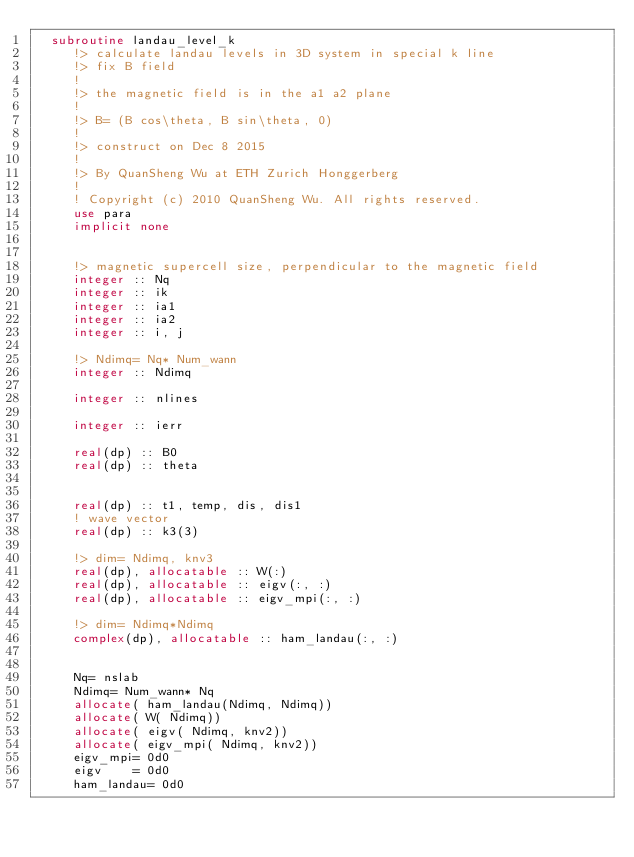Convert code to text. <code><loc_0><loc_0><loc_500><loc_500><_FORTRAN_>  subroutine landau_level_k
     !> calculate landau levels in 3D system in special k line
     !> fix B field
     !
     !> the magnetic field is in the a1 a2 plane
     !
     !> B= (B cos\theta, B sin\theta, 0)
     !
     !> construct on Dec 8 2015
     !
     !> By QuanSheng Wu at ETH Zurich Honggerberg
     !
     ! Copyright (c) 2010 QuanSheng Wu. All rights reserved.
     use para
     implicit none


     !> magnetic supercell size, perpendicular to the magnetic field
     integer :: Nq
     integer :: ik
     integer :: ia1
     integer :: ia2
     integer :: i, j

     !> Ndimq= Nq* Num_wann
     integer :: Ndimq

     integer :: nlines

     integer :: ierr

     real(dp) :: B0
     real(dp) :: theta


     real(dp) :: t1, temp, dis, dis1
     ! wave vector 
     real(dp) :: k3(3)

     !> dim= Ndimq, knv3
     real(dp), allocatable :: W(:)
     real(dp), allocatable :: eigv(:, :)
     real(dp), allocatable :: eigv_mpi(:, :)

     !> dim= Ndimq*Ndimq
     complex(dp), allocatable :: ham_landau(:, :)


     Nq= nslab
     Ndimq= Num_wann* Nq
     allocate( ham_landau(Ndimq, Ndimq))
     allocate( W( Ndimq))
     allocate( eigv( Ndimq, knv2))
     allocate( eigv_mpi( Ndimq, knv2))
     eigv_mpi= 0d0
     eigv    = 0d0
     ham_landau= 0d0

</code> 